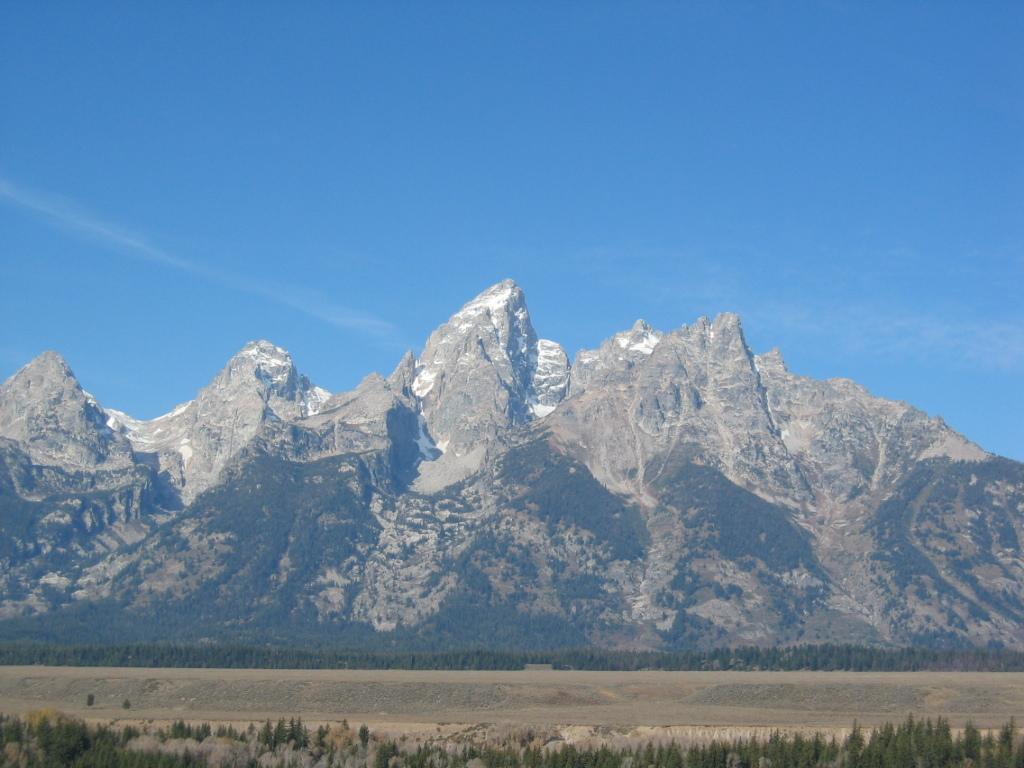In one or two sentences, can you explain what this image depicts? In the center of the image we can see the mountains. We can also see a group of trees and the sky which looks cloudy. 